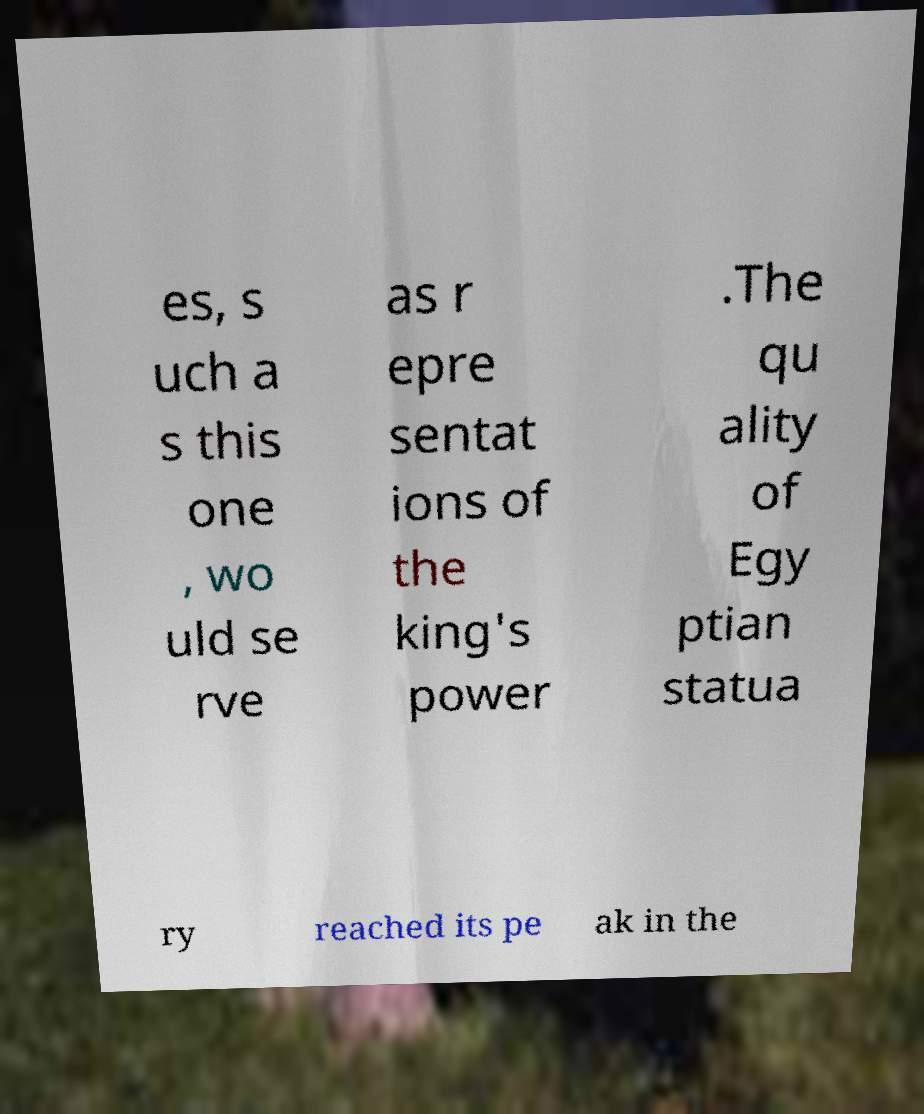What messages or text are displayed in this image? I need them in a readable, typed format. es, s uch a s this one , wo uld se rve as r epre sentat ions of the king's power .The qu ality of Egy ptian statua ry reached its pe ak in the 